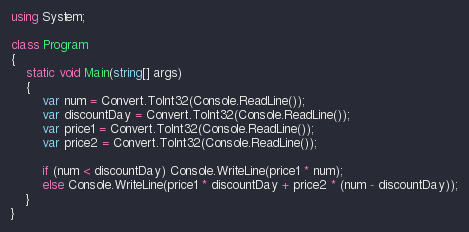<code> <loc_0><loc_0><loc_500><loc_500><_C#_>using System;

class Program
{
    static void Main(string[] args)
    {
        var num = Convert.ToInt32(Console.ReadLine());
        var discountDay = Convert.ToInt32(Console.ReadLine());
        var price1 = Convert.ToInt32(Console.ReadLine());
        var price2 = Convert.ToInt32(Console.ReadLine());

        if (num < discountDay) Console.WriteLine(price1 * num);
        else Console.WriteLine(price1 * discountDay + price2 * (num - discountDay));
    }
}</code> 